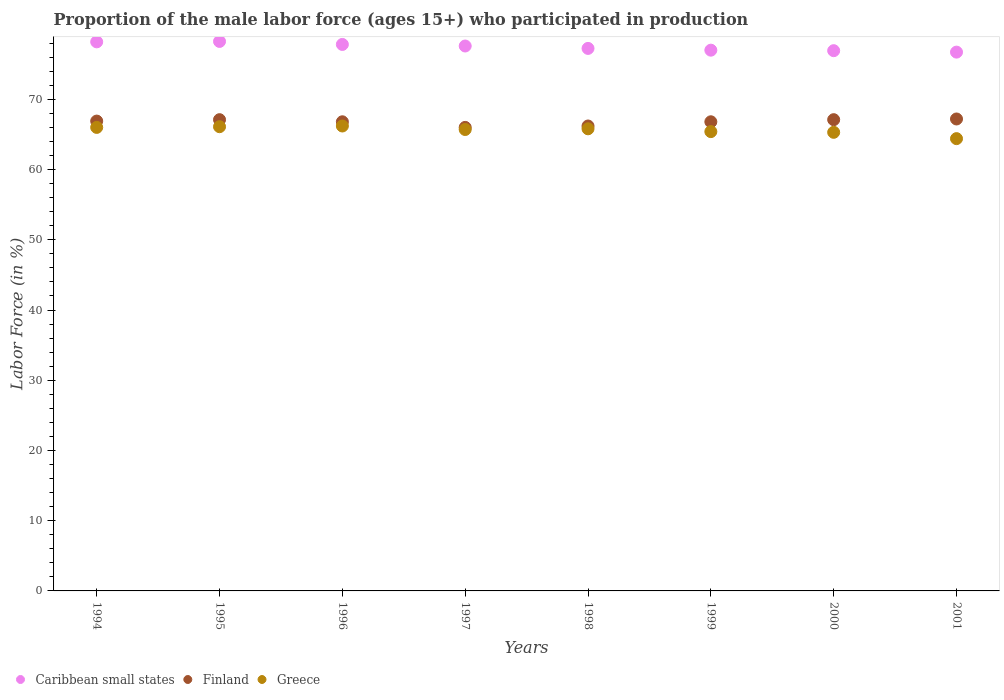How many different coloured dotlines are there?
Give a very brief answer. 3. Is the number of dotlines equal to the number of legend labels?
Your answer should be very brief. Yes. What is the proportion of the male labor force who participated in production in Caribbean small states in 1998?
Keep it short and to the point. 77.25. Across all years, what is the maximum proportion of the male labor force who participated in production in Greece?
Offer a terse response. 66.2. Across all years, what is the minimum proportion of the male labor force who participated in production in Greece?
Ensure brevity in your answer.  64.4. In which year was the proportion of the male labor force who participated in production in Finland minimum?
Ensure brevity in your answer.  1997. What is the total proportion of the male labor force who participated in production in Greece in the graph?
Your answer should be compact. 524.9. What is the difference between the proportion of the male labor force who participated in production in Caribbean small states in 1996 and that in 1999?
Offer a terse response. 0.82. What is the difference between the proportion of the male labor force who participated in production in Greece in 1994 and the proportion of the male labor force who participated in production in Caribbean small states in 1995?
Offer a terse response. -12.24. What is the average proportion of the male labor force who participated in production in Caribbean small states per year?
Provide a short and direct response. 77.46. In the year 2001, what is the difference between the proportion of the male labor force who participated in production in Caribbean small states and proportion of the male labor force who participated in production in Finland?
Your response must be concise. 9.52. In how many years, is the proportion of the male labor force who participated in production in Caribbean small states greater than 66 %?
Provide a succinct answer. 8. What is the ratio of the proportion of the male labor force who participated in production in Greece in 1997 to that in 1999?
Keep it short and to the point. 1. Is the proportion of the male labor force who participated in production in Greece in 2000 less than that in 2001?
Offer a terse response. No. Is the difference between the proportion of the male labor force who participated in production in Caribbean small states in 1997 and 1999 greater than the difference between the proportion of the male labor force who participated in production in Finland in 1997 and 1999?
Make the answer very short. Yes. What is the difference between the highest and the second highest proportion of the male labor force who participated in production in Caribbean small states?
Ensure brevity in your answer.  0.06. What is the difference between the highest and the lowest proportion of the male labor force who participated in production in Caribbean small states?
Keep it short and to the point. 1.52. Is it the case that in every year, the sum of the proportion of the male labor force who participated in production in Caribbean small states and proportion of the male labor force who participated in production in Finland  is greater than the proportion of the male labor force who participated in production in Greece?
Make the answer very short. Yes. Does the proportion of the male labor force who participated in production in Greece monotonically increase over the years?
Give a very brief answer. No. Is the proportion of the male labor force who participated in production in Greece strictly greater than the proportion of the male labor force who participated in production in Finland over the years?
Ensure brevity in your answer.  No. Is the proportion of the male labor force who participated in production in Finland strictly less than the proportion of the male labor force who participated in production in Caribbean small states over the years?
Offer a terse response. Yes. How many years are there in the graph?
Your answer should be compact. 8. Does the graph contain any zero values?
Offer a terse response. No. Does the graph contain grids?
Your answer should be very brief. No. What is the title of the graph?
Your answer should be compact. Proportion of the male labor force (ages 15+) who participated in production. What is the label or title of the Y-axis?
Keep it short and to the point. Labor Force (in %). What is the Labor Force (in %) in Caribbean small states in 1994?
Offer a very short reply. 78.18. What is the Labor Force (in %) in Finland in 1994?
Offer a very short reply. 66.9. What is the Labor Force (in %) in Greece in 1994?
Give a very brief answer. 66. What is the Labor Force (in %) in Caribbean small states in 1995?
Provide a succinct answer. 78.24. What is the Labor Force (in %) in Finland in 1995?
Offer a terse response. 67.1. What is the Labor Force (in %) of Greece in 1995?
Your response must be concise. 66.1. What is the Labor Force (in %) in Caribbean small states in 1996?
Your answer should be compact. 77.81. What is the Labor Force (in %) of Finland in 1996?
Provide a succinct answer. 66.8. What is the Labor Force (in %) in Greece in 1996?
Keep it short and to the point. 66.2. What is the Labor Force (in %) of Caribbean small states in 1997?
Offer a very short reply. 77.59. What is the Labor Force (in %) in Finland in 1997?
Offer a terse response. 66. What is the Labor Force (in %) of Greece in 1997?
Offer a very short reply. 65.7. What is the Labor Force (in %) of Caribbean small states in 1998?
Your answer should be very brief. 77.25. What is the Labor Force (in %) of Finland in 1998?
Offer a very short reply. 66.2. What is the Labor Force (in %) in Greece in 1998?
Provide a short and direct response. 65.8. What is the Labor Force (in %) in Caribbean small states in 1999?
Your answer should be very brief. 77. What is the Labor Force (in %) in Finland in 1999?
Make the answer very short. 66.8. What is the Labor Force (in %) of Greece in 1999?
Provide a succinct answer. 65.4. What is the Labor Force (in %) of Caribbean small states in 2000?
Keep it short and to the point. 76.92. What is the Labor Force (in %) of Finland in 2000?
Provide a succinct answer. 67.1. What is the Labor Force (in %) of Greece in 2000?
Provide a short and direct response. 65.3. What is the Labor Force (in %) of Caribbean small states in 2001?
Keep it short and to the point. 76.72. What is the Labor Force (in %) in Finland in 2001?
Your answer should be compact. 67.2. What is the Labor Force (in %) in Greece in 2001?
Make the answer very short. 64.4. Across all years, what is the maximum Labor Force (in %) of Caribbean small states?
Provide a short and direct response. 78.24. Across all years, what is the maximum Labor Force (in %) of Finland?
Provide a short and direct response. 67.2. Across all years, what is the maximum Labor Force (in %) of Greece?
Make the answer very short. 66.2. Across all years, what is the minimum Labor Force (in %) in Caribbean small states?
Make the answer very short. 76.72. Across all years, what is the minimum Labor Force (in %) of Greece?
Your answer should be compact. 64.4. What is the total Labor Force (in %) of Caribbean small states in the graph?
Ensure brevity in your answer.  619.71. What is the total Labor Force (in %) of Finland in the graph?
Keep it short and to the point. 534.1. What is the total Labor Force (in %) of Greece in the graph?
Offer a terse response. 524.9. What is the difference between the Labor Force (in %) of Caribbean small states in 1994 and that in 1995?
Provide a short and direct response. -0.06. What is the difference between the Labor Force (in %) of Greece in 1994 and that in 1995?
Provide a short and direct response. -0.1. What is the difference between the Labor Force (in %) in Caribbean small states in 1994 and that in 1996?
Provide a succinct answer. 0.37. What is the difference between the Labor Force (in %) in Greece in 1994 and that in 1996?
Provide a succinct answer. -0.2. What is the difference between the Labor Force (in %) of Caribbean small states in 1994 and that in 1997?
Offer a terse response. 0.59. What is the difference between the Labor Force (in %) in Finland in 1994 and that in 1997?
Your answer should be compact. 0.9. What is the difference between the Labor Force (in %) in Caribbean small states in 1994 and that in 1998?
Your answer should be compact. 0.94. What is the difference between the Labor Force (in %) of Greece in 1994 and that in 1998?
Make the answer very short. 0.2. What is the difference between the Labor Force (in %) of Caribbean small states in 1994 and that in 1999?
Offer a terse response. 1.19. What is the difference between the Labor Force (in %) in Caribbean small states in 1994 and that in 2000?
Your answer should be very brief. 1.26. What is the difference between the Labor Force (in %) in Finland in 1994 and that in 2000?
Give a very brief answer. -0.2. What is the difference between the Labor Force (in %) in Greece in 1994 and that in 2000?
Provide a succinct answer. 0.7. What is the difference between the Labor Force (in %) of Caribbean small states in 1994 and that in 2001?
Provide a short and direct response. 1.46. What is the difference between the Labor Force (in %) of Finland in 1994 and that in 2001?
Keep it short and to the point. -0.3. What is the difference between the Labor Force (in %) of Caribbean small states in 1995 and that in 1996?
Make the answer very short. 0.43. What is the difference between the Labor Force (in %) of Greece in 1995 and that in 1996?
Your answer should be compact. -0.1. What is the difference between the Labor Force (in %) of Caribbean small states in 1995 and that in 1997?
Keep it short and to the point. 0.65. What is the difference between the Labor Force (in %) of Greece in 1995 and that in 1997?
Ensure brevity in your answer.  0.4. What is the difference between the Labor Force (in %) in Caribbean small states in 1995 and that in 1998?
Provide a succinct answer. 0.99. What is the difference between the Labor Force (in %) of Finland in 1995 and that in 1998?
Your answer should be compact. 0.9. What is the difference between the Labor Force (in %) in Greece in 1995 and that in 1998?
Ensure brevity in your answer.  0.3. What is the difference between the Labor Force (in %) of Caribbean small states in 1995 and that in 1999?
Your response must be concise. 1.24. What is the difference between the Labor Force (in %) of Greece in 1995 and that in 1999?
Your response must be concise. 0.7. What is the difference between the Labor Force (in %) of Caribbean small states in 1995 and that in 2000?
Offer a terse response. 1.32. What is the difference between the Labor Force (in %) in Finland in 1995 and that in 2000?
Keep it short and to the point. 0. What is the difference between the Labor Force (in %) of Greece in 1995 and that in 2000?
Provide a succinct answer. 0.8. What is the difference between the Labor Force (in %) of Caribbean small states in 1995 and that in 2001?
Give a very brief answer. 1.52. What is the difference between the Labor Force (in %) of Finland in 1995 and that in 2001?
Offer a terse response. -0.1. What is the difference between the Labor Force (in %) of Greece in 1995 and that in 2001?
Your answer should be very brief. 1.7. What is the difference between the Labor Force (in %) of Caribbean small states in 1996 and that in 1997?
Ensure brevity in your answer.  0.22. What is the difference between the Labor Force (in %) in Finland in 1996 and that in 1997?
Offer a terse response. 0.8. What is the difference between the Labor Force (in %) of Caribbean small states in 1996 and that in 1998?
Your answer should be very brief. 0.57. What is the difference between the Labor Force (in %) of Finland in 1996 and that in 1998?
Make the answer very short. 0.6. What is the difference between the Labor Force (in %) of Greece in 1996 and that in 1998?
Your answer should be compact. 0.4. What is the difference between the Labor Force (in %) of Caribbean small states in 1996 and that in 1999?
Your response must be concise. 0.82. What is the difference between the Labor Force (in %) of Caribbean small states in 1996 and that in 2000?
Your response must be concise. 0.89. What is the difference between the Labor Force (in %) of Greece in 1996 and that in 2000?
Ensure brevity in your answer.  0.9. What is the difference between the Labor Force (in %) of Caribbean small states in 1996 and that in 2001?
Give a very brief answer. 1.09. What is the difference between the Labor Force (in %) in Finland in 1996 and that in 2001?
Give a very brief answer. -0.4. What is the difference between the Labor Force (in %) in Caribbean small states in 1997 and that in 1998?
Offer a very short reply. 0.34. What is the difference between the Labor Force (in %) of Greece in 1997 and that in 1998?
Keep it short and to the point. -0.1. What is the difference between the Labor Force (in %) of Caribbean small states in 1997 and that in 1999?
Make the answer very short. 0.59. What is the difference between the Labor Force (in %) of Finland in 1997 and that in 1999?
Offer a terse response. -0.8. What is the difference between the Labor Force (in %) in Greece in 1997 and that in 1999?
Your answer should be compact. 0.3. What is the difference between the Labor Force (in %) of Caribbean small states in 1997 and that in 2000?
Offer a terse response. 0.67. What is the difference between the Labor Force (in %) of Greece in 1997 and that in 2000?
Keep it short and to the point. 0.4. What is the difference between the Labor Force (in %) of Caribbean small states in 1997 and that in 2001?
Offer a terse response. 0.87. What is the difference between the Labor Force (in %) of Caribbean small states in 1998 and that in 1999?
Offer a very short reply. 0.25. What is the difference between the Labor Force (in %) in Finland in 1998 and that in 1999?
Ensure brevity in your answer.  -0.6. What is the difference between the Labor Force (in %) in Greece in 1998 and that in 1999?
Offer a very short reply. 0.4. What is the difference between the Labor Force (in %) of Caribbean small states in 1998 and that in 2000?
Give a very brief answer. 0.32. What is the difference between the Labor Force (in %) in Finland in 1998 and that in 2000?
Ensure brevity in your answer.  -0.9. What is the difference between the Labor Force (in %) of Caribbean small states in 1998 and that in 2001?
Offer a terse response. 0.53. What is the difference between the Labor Force (in %) of Finland in 1998 and that in 2001?
Your answer should be very brief. -1. What is the difference between the Labor Force (in %) of Caribbean small states in 1999 and that in 2000?
Your answer should be very brief. 0.07. What is the difference between the Labor Force (in %) in Greece in 1999 and that in 2000?
Keep it short and to the point. 0.1. What is the difference between the Labor Force (in %) in Caribbean small states in 1999 and that in 2001?
Offer a terse response. 0.28. What is the difference between the Labor Force (in %) in Greece in 1999 and that in 2001?
Your answer should be compact. 1. What is the difference between the Labor Force (in %) in Caribbean small states in 2000 and that in 2001?
Ensure brevity in your answer.  0.2. What is the difference between the Labor Force (in %) in Finland in 2000 and that in 2001?
Give a very brief answer. -0.1. What is the difference between the Labor Force (in %) in Caribbean small states in 1994 and the Labor Force (in %) in Finland in 1995?
Give a very brief answer. 11.08. What is the difference between the Labor Force (in %) in Caribbean small states in 1994 and the Labor Force (in %) in Greece in 1995?
Ensure brevity in your answer.  12.08. What is the difference between the Labor Force (in %) of Finland in 1994 and the Labor Force (in %) of Greece in 1995?
Your answer should be compact. 0.8. What is the difference between the Labor Force (in %) of Caribbean small states in 1994 and the Labor Force (in %) of Finland in 1996?
Ensure brevity in your answer.  11.38. What is the difference between the Labor Force (in %) in Caribbean small states in 1994 and the Labor Force (in %) in Greece in 1996?
Keep it short and to the point. 11.98. What is the difference between the Labor Force (in %) in Finland in 1994 and the Labor Force (in %) in Greece in 1996?
Provide a succinct answer. 0.7. What is the difference between the Labor Force (in %) of Caribbean small states in 1994 and the Labor Force (in %) of Finland in 1997?
Offer a terse response. 12.18. What is the difference between the Labor Force (in %) in Caribbean small states in 1994 and the Labor Force (in %) in Greece in 1997?
Ensure brevity in your answer.  12.48. What is the difference between the Labor Force (in %) of Finland in 1994 and the Labor Force (in %) of Greece in 1997?
Make the answer very short. 1.2. What is the difference between the Labor Force (in %) in Caribbean small states in 1994 and the Labor Force (in %) in Finland in 1998?
Provide a short and direct response. 11.98. What is the difference between the Labor Force (in %) of Caribbean small states in 1994 and the Labor Force (in %) of Greece in 1998?
Offer a very short reply. 12.38. What is the difference between the Labor Force (in %) of Finland in 1994 and the Labor Force (in %) of Greece in 1998?
Keep it short and to the point. 1.1. What is the difference between the Labor Force (in %) in Caribbean small states in 1994 and the Labor Force (in %) in Finland in 1999?
Provide a short and direct response. 11.38. What is the difference between the Labor Force (in %) in Caribbean small states in 1994 and the Labor Force (in %) in Greece in 1999?
Your response must be concise. 12.78. What is the difference between the Labor Force (in %) in Finland in 1994 and the Labor Force (in %) in Greece in 1999?
Offer a terse response. 1.5. What is the difference between the Labor Force (in %) in Caribbean small states in 1994 and the Labor Force (in %) in Finland in 2000?
Make the answer very short. 11.08. What is the difference between the Labor Force (in %) of Caribbean small states in 1994 and the Labor Force (in %) of Greece in 2000?
Your response must be concise. 12.88. What is the difference between the Labor Force (in %) of Caribbean small states in 1994 and the Labor Force (in %) of Finland in 2001?
Your answer should be compact. 10.98. What is the difference between the Labor Force (in %) in Caribbean small states in 1994 and the Labor Force (in %) in Greece in 2001?
Give a very brief answer. 13.78. What is the difference between the Labor Force (in %) of Finland in 1994 and the Labor Force (in %) of Greece in 2001?
Your answer should be compact. 2.5. What is the difference between the Labor Force (in %) in Caribbean small states in 1995 and the Labor Force (in %) in Finland in 1996?
Offer a terse response. 11.44. What is the difference between the Labor Force (in %) of Caribbean small states in 1995 and the Labor Force (in %) of Greece in 1996?
Give a very brief answer. 12.04. What is the difference between the Labor Force (in %) in Caribbean small states in 1995 and the Labor Force (in %) in Finland in 1997?
Offer a very short reply. 12.24. What is the difference between the Labor Force (in %) of Caribbean small states in 1995 and the Labor Force (in %) of Greece in 1997?
Ensure brevity in your answer.  12.54. What is the difference between the Labor Force (in %) in Finland in 1995 and the Labor Force (in %) in Greece in 1997?
Provide a succinct answer. 1.4. What is the difference between the Labor Force (in %) of Caribbean small states in 1995 and the Labor Force (in %) of Finland in 1998?
Give a very brief answer. 12.04. What is the difference between the Labor Force (in %) of Caribbean small states in 1995 and the Labor Force (in %) of Greece in 1998?
Offer a terse response. 12.44. What is the difference between the Labor Force (in %) in Finland in 1995 and the Labor Force (in %) in Greece in 1998?
Your answer should be very brief. 1.3. What is the difference between the Labor Force (in %) of Caribbean small states in 1995 and the Labor Force (in %) of Finland in 1999?
Provide a succinct answer. 11.44. What is the difference between the Labor Force (in %) of Caribbean small states in 1995 and the Labor Force (in %) of Greece in 1999?
Provide a succinct answer. 12.84. What is the difference between the Labor Force (in %) in Finland in 1995 and the Labor Force (in %) in Greece in 1999?
Your response must be concise. 1.7. What is the difference between the Labor Force (in %) of Caribbean small states in 1995 and the Labor Force (in %) of Finland in 2000?
Your answer should be very brief. 11.14. What is the difference between the Labor Force (in %) of Caribbean small states in 1995 and the Labor Force (in %) of Greece in 2000?
Your answer should be compact. 12.94. What is the difference between the Labor Force (in %) of Caribbean small states in 1995 and the Labor Force (in %) of Finland in 2001?
Your response must be concise. 11.04. What is the difference between the Labor Force (in %) of Caribbean small states in 1995 and the Labor Force (in %) of Greece in 2001?
Your answer should be very brief. 13.84. What is the difference between the Labor Force (in %) in Caribbean small states in 1996 and the Labor Force (in %) in Finland in 1997?
Ensure brevity in your answer.  11.81. What is the difference between the Labor Force (in %) in Caribbean small states in 1996 and the Labor Force (in %) in Greece in 1997?
Provide a short and direct response. 12.11. What is the difference between the Labor Force (in %) in Caribbean small states in 1996 and the Labor Force (in %) in Finland in 1998?
Offer a terse response. 11.61. What is the difference between the Labor Force (in %) in Caribbean small states in 1996 and the Labor Force (in %) in Greece in 1998?
Your answer should be very brief. 12.01. What is the difference between the Labor Force (in %) in Finland in 1996 and the Labor Force (in %) in Greece in 1998?
Give a very brief answer. 1. What is the difference between the Labor Force (in %) in Caribbean small states in 1996 and the Labor Force (in %) in Finland in 1999?
Your answer should be compact. 11.01. What is the difference between the Labor Force (in %) of Caribbean small states in 1996 and the Labor Force (in %) of Greece in 1999?
Provide a short and direct response. 12.41. What is the difference between the Labor Force (in %) of Finland in 1996 and the Labor Force (in %) of Greece in 1999?
Provide a succinct answer. 1.4. What is the difference between the Labor Force (in %) in Caribbean small states in 1996 and the Labor Force (in %) in Finland in 2000?
Offer a terse response. 10.71. What is the difference between the Labor Force (in %) of Caribbean small states in 1996 and the Labor Force (in %) of Greece in 2000?
Give a very brief answer. 12.51. What is the difference between the Labor Force (in %) in Finland in 1996 and the Labor Force (in %) in Greece in 2000?
Offer a very short reply. 1.5. What is the difference between the Labor Force (in %) of Caribbean small states in 1996 and the Labor Force (in %) of Finland in 2001?
Keep it short and to the point. 10.61. What is the difference between the Labor Force (in %) of Caribbean small states in 1996 and the Labor Force (in %) of Greece in 2001?
Keep it short and to the point. 13.41. What is the difference between the Labor Force (in %) of Caribbean small states in 1997 and the Labor Force (in %) of Finland in 1998?
Make the answer very short. 11.39. What is the difference between the Labor Force (in %) of Caribbean small states in 1997 and the Labor Force (in %) of Greece in 1998?
Give a very brief answer. 11.79. What is the difference between the Labor Force (in %) in Caribbean small states in 1997 and the Labor Force (in %) in Finland in 1999?
Ensure brevity in your answer.  10.79. What is the difference between the Labor Force (in %) of Caribbean small states in 1997 and the Labor Force (in %) of Greece in 1999?
Your answer should be very brief. 12.19. What is the difference between the Labor Force (in %) of Caribbean small states in 1997 and the Labor Force (in %) of Finland in 2000?
Make the answer very short. 10.49. What is the difference between the Labor Force (in %) in Caribbean small states in 1997 and the Labor Force (in %) in Greece in 2000?
Your answer should be very brief. 12.29. What is the difference between the Labor Force (in %) in Caribbean small states in 1997 and the Labor Force (in %) in Finland in 2001?
Your answer should be very brief. 10.39. What is the difference between the Labor Force (in %) in Caribbean small states in 1997 and the Labor Force (in %) in Greece in 2001?
Offer a terse response. 13.19. What is the difference between the Labor Force (in %) in Caribbean small states in 1998 and the Labor Force (in %) in Finland in 1999?
Give a very brief answer. 10.45. What is the difference between the Labor Force (in %) of Caribbean small states in 1998 and the Labor Force (in %) of Greece in 1999?
Offer a terse response. 11.85. What is the difference between the Labor Force (in %) of Finland in 1998 and the Labor Force (in %) of Greece in 1999?
Ensure brevity in your answer.  0.8. What is the difference between the Labor Force (in %) in Caribbean small states in 1998 and the Labor Force (in %) in Finland in 2000?
Provide a short and direct response. 10.15. What is the difference between the Labor Force (in %) of Caribbean small states in 1998 and the Labor Force (in %) of Greece in 2000?
Offer a very short reply. 11.95. What is the difference between the Labor Force (in %) of Finland in 1998 and the Labor Force (in %) of Greece in 2000?
Ensure brevity in your answer.  0.9. What is the difference between the Labor Force (in %) in Caribbean small states in 1998 and the Labor Force (in %) in Finland in 2001?
Make the answer very short. 10.05. What is the difference between the Labor Force (in %) of Caribbean small states in 1998 and the Labor Force (in %) of Greece in 2001?
Your answer should be very brief. 12.85. What is the difference between the Labor Force (in %) of Caribbean small states in 1999 and the Labor Force (in %) of Finland in 2000?
Give a very brief answer. 9.9. What is the difference between the Labor Force (in %) of Caribbean small states in 1999 and the Labor Force (in %) of Greece in 2000?
Your answer should be very brief. 11.7. What is the difference between the Labor Force (in %) in Caribbean small states in 1999 and the Labor Force (in %) in Finland in 2001?
Keep it short and to the point. 9.8. What is the difference between the Labor Force (in %) of Caribbean small states in 1999 and the Labor Force (in %) of Greece in 2001?
Make the answer very short. 12.6. What is the difference between the Labor Force (in %) in Caribbean small states in 2000 and the Labor Force (in %) in Finland in 2001?
Ensure brevity in your answer.  9.72. What is the difference between the Labor Force (in %) of Caribbean small states in 2000 and the Labor Force (in %) of Greece in 2001?
Offer a very short reply. 12.52. What is the average Labor Force (in %) in Caribbean small states per year?
Provide a short and direct response. 77.46. What is the average Labor Force (in %) in Finland per year?
Your response must be concise. 66.76. What is the average Labor Force (in %) in Greece per year?
Provide a short and direct response. 65.61. In the year 1994, what is the difference between the Labor Force (in %) of Caribbean small states and Labor Force (in %) of Finland?
Offer a terse response. 11.28. In the year 1994, what is the difference between the Labor Force (in %) of Caribbean small states and Labor Force (in %) of Greece?
Your answer should be very brief. 12.18. In the year 1995, what is the difference between the Labor Force (in %) of Caribbean small states and Labor Force (in %) of Finland?
Provide a succinct answer. 11.14. In the year 1995, what is the difference between the Labor Force (in %) in Caribbean small states and Labor Force (in %) in Greece?
Offer a very short reply. 12.14. In the year 1996, what is the difference between the Labor Force (in %) of Caribbean small states and Labor Force (in %) of Finland?
Provide a succinct answer. 11.01. In the year 1996, what is the difference between the Labor Force (in %) in Caribbean small states and Labor Force (in %) in Greece?
Give a very brief answer. 11.61. In the year 1996, what is the difference between the Labor Force (in %) in Finland and Labor Force (in %) in Greece?
Keep it short and to the point. 0.6. In the year 1997, what is the difference between the Labor Force (in %) of Caribbean small states and Labor Force (in %) of Finland?
Offer a terse response. 11.59. In the year 1997, what is the difference between the Labor Force (in %) of Caribbean small states and Labor Force (in %) of Greece?
Your response must be concise. 11.89. In the year 1998, what is the difference between the Labor Force (in %) of Caribbean small states and Labor Force (in %) of Finland?
Offer a very short reply. 11.05. In the year 1998, what is the difference between the Labor Force (in %) of Caribbean small states and Labor Force (in %) of Greece?
Keep it short and to the point. 11.45. In the year 1998, what is the difference between the Labor Force (in %) of Finland and Labor Force (in %) of Greece?
Your response must be concise. 0.4. In the year 1999, what is the difference between the Labor Force (in %) of Caribbean small states and Labor Force (in %) of Finland?
Ensure brevity in your answer.  10.2. In the year 1999, what is the difference between the Labor Force (in %) in Caribbean small states and Labor Force (in %) in Greece?
Your answer should be compact. 11.6. In the year 2000, what is the difference between the Labor Force (in %) in Caribbean small states and Labor Force (in %) in Finland?
Make the answer very short. 9.82. In the year 2000, what is the difference between the Labor Force (in %) in Caribbean small states and Labor Force (in %) in Greece?
Offer a very short reply. 11.62. In the year 2001, what is the difference between the Labor Force (in %) of Caribbean small states and Labor Force (in %) of Finland?
Offer a terse response. 9.52. In the year 2001, what is the difference between the Labor Force (in %) of Caribbean small states and Labor Force (in %) of Greece?
Your response must be concise. 12.32. In the year 2001, what is the difference between the Labor Force (in %) in Finland and Labor Force (in %) in Greece?
Provide a short and direct response. 2.8. What is the ratio of the Labor Force (in %) of Finland in 1994 to that in 1995?
Make the answer very short. 1. What is the ratio of the Labor Force (in %) in Caribbean small states in 1994 to that in 1996?
Ensure brevity in your answer.  1. What is the ratio of the Labor Force (in %) of Finland in 1994 to that in 1996?
Make the answer very short. 1. What is the ratio of the Labor Force (in %) in Greece in 1994 to that in 1996?
Keep it short and to the point. 1. What is the ratio of the Labor Force (in %) in Caribbean small states in 1994 to that in 1997?
Your answer should be compact. 1.01. What is the ratio of the Labor Force (in %) of Finland in 1994 to that in 1997?
Your response must be concise. 1.01. What is the ratio of the Labor Force (in %) of Greece in 1994 to that in 1997?
Provide a short and direct response. 1. What is the ratio of the Labor Force (in %) of Caribbean small states in 1994 to that in 1998?
Ensure brevity in your answer.  1.01. What is the ratio of the Labor Force (in %) of Finland in 1994 to that in 1998?
Make the answer very short. 1.01. What is the ratio of the Labor Force (in %) of Greece in 1994 to that in 1998?
Make the answer very short. 1. What is the ratio of the Labor Force (in %) in Caribbean small states in 1994 to that in 1999?
Provide a succinct answer. 1.02. What is the ratio of the Labor Force (in %) in Greece in 1994 to that in 1999?
Make the answer very short. 1.01. What is the ratio of the Labor Force (in %) in Caribbean small states in 1994 to that in 2000?
Offer a terse response. 1.02. What is the ratio of the Labor Force (in %) in Greece in 1994 to that in 2000?
Provide a succinct answer. 1.01. What is the ratio of the Labor Force (in %) in Caribbean small states in 1994 to that in 2001?
Offer a terse response. 1.02. What is the ratio of the Labor Force (in %) in Finland in 1994 to that in 2001?
Keep it short and to the point. 1. What is the ratio of the Labor Force (in %) in Greece in 1994 to that in 2001?
Your answer should be compact. 1.02. What is the ratio of the Labor Force (in %) in Caribbean small states in 1995 to that in 1996?
Your response must be concise. 1.01. What is the ratio of the Labor Force (in %) in Caribbean small states in 1995 to that in 1997?
Make the answer very short. 1.01. What is the ratio of the Labor Force (in %) of Finland in 1995 to that in 1997?
Your answer should be very brief. 1.02. What is the ratio of the Labor Force (in %) of Greece in 1995 to that in 1997?
Your answer should be compact. 1.01. What is the ratio of the Labor Force (in %) of Caribbean small states in 1995 to that in 1998?
Keep it short and to the point. 1.01. What is the ratio of the Labor Force (in %) of Finland in 1995 to that in 1998?
Ensure brevity in your answer.  1.01. What is the ratio of the Labor Force (in %) in Caribbean small states in 1995 to that in 1999?
Make the answer very short. 1.02. What is the ratio of the Labor Force (in %) of Greece in 1995 to that in 1999?
Provide a succinct answer. 1.01. What is the ratio of the Labor Force (in %) of Caribbean small states in 1995 to that in 2000?
Your answer should be very brief. 1.02. What is the ratio of the Labor Force (in %) in Finland in 1995 to that in 2000?
Provide a succinct answer. 1. What is the ratio of the Labor Force (in %) in Greece in 1995 to that in 2000?
Provide a succinct answer. 1.01. What is the ratio of the Labor Force (in %) in Caribbean small states in 1995 to that in 2001?
Provide a succinct answer. 1.02. What is the ratio of the Labor Force (in %) in Greece in 1995 to that in 2001?
Offer a very short reply. 1.03. What is the ratio of the Labor Force (in %) in Finland in 1996 to that in 1997?
Your answer should be compact. 1.01. What is the ratio of the Labor Force (in %) of Greece in 1996 to that in 1997?
Keep it short and to the point. 1.01. What is the ratio of the Labor Force (in %) of Caribbean small states in 1996 to that in 1998?
Your answer should be compact. 1.01. What is the ratio of the Labor Force (in %) of Finland in 1996 to that in 1998?
Ensure brevity in your answer.  1.01. What is the ratio of the Labor Force (in %) in Greece in 1996 to that in 1998?
Ensure brevity in your answer.  1.01. What is the ratio of the Labor Force (in %) in Caribbean small states in 1996 to that in 1999?
Provide a succinct answer. 1.01. What is the ratio of the Labor Force (in %) of Finland in 1996 to that in 1999?
Keep it short and to the point. 1. What is the ratio of the Labor Force (in %) of Greece in 1996 to that in 1999?
Provide a short and direct response. 1.01. What is the ratio of the Labor Force (in %) of Caribbean small states in 1996 to that in 2000?
Ensure brevity in your answer.  1.01. What is the ratio of the Labor Force (in %) of Greece in 1996 to that in 2000?
Your answer should be very brief. 1.01. What is the ratio of the Labor Force (in %) in Caribbean small states in 1996 to that in 2001?
Ensure brevity in your answer.  1.01. What is the ratio of the Labor Force (in %) in Finland in 1996 to that in 2001?
Make the answer very short. 0.99. What is the ratio of the Labor Force (in %) of Greece in 1996 to that in 2001?
Your response must be concise. 1.03. What is the ratio of the Labor Force (in %) in Caribbean small states in 1997 to that in 1998?
Provide a succinct answer. 1. What is the ratio of the Labor Force (in %) of Greece in 1997 to that in 1998?
Keep it short and to the point. 1. What is the ratio of the Labor Force (in %) in Caribbean small states in 1997 to that in 1999?
Ensure brevity in your answer.  1.01. What is the ratio of the Labor Force (in %) of Greece in 1997 to that in 1999?
Ensure brevity in your answer.  1. What is the ratio of the Labor Force (in %) of Caribbean small states in 1997 to that in 2000?
Offer a very short reply. 1.01. What is the ratio of the Labor Force (in %) in Finland in 1997 to that in 2000?
Keep it short and to the point. 0.98. What is the ratio of the Labor Force (in %) in Greece in 1997 to that in 2000?
Your answer should be very brief. 1.01. What is the ratio of the Labor Force (in %) of Caribbean small states in 1997 to that in 2001?
Your answer should be compact. 1.01. What is the ratio of the Labor Force (in %) in Finland in 1997 to that in 2001?
Keep it short and to the point. 0.98. What is the ratio of the Labor Force (in %) in Greece in 1997 to that in 2001?
Provide a short and direct response. 1.02. What is the ratio of the Labor Force (in %) of Greece in 1998 to that in 1999?
Make the answer very short. 1.01. What is the ratio of the Labor Force (in %) of Finland in 1998 to that in 2000?
Offer a terse response. 0.99. What is the ratio of the Labor Force (in %) in Greece in 1998 to that in 2000?
Offer a very short reply. 1.01. What is the ratio of the Labor Force (in %) of Finland in 1998 to that in 2001?
Offer a terse response. 0.99. What is the ratio of the Labor Force (in %) of Greece in 1998 to that in 2001?
Offer a very short reply. 1.02. What is the ratio of the Labor Force (in %) of Caribbean small states in 1999 to that in 2000?
Offer a terse response. 1. What is the ratio of the Labor Force (in %) of Greece in 1999 to that in 2000?
Your answer should be very brief. 1. What is the ratio of the Labor Force (in %) in Greece in 1999 to that in 2001?
Offer a very short reply. 1.02. What is the ratio of the Labor Force (in %) of Caribbean small states in 2000 to that in 2001?
Provide a short and direct response. 1. What is the ratio of the Labor Force (in %) of Finland in 2000 to that in 2001?
Offer a very short reply. 1. What is the difference between the highest and the second highest Labor Force (in %) of Caribbean small states?
Your answer should be compact. 0.06. What is the difference between the highest and the second highest Labor Force (in %) of Greece?
Your response must be concise. 0.1. What is the difference between the highest and the lowest Labor Force (in %) in Caribbean small states?
Your answer should be very brief. 1.52. What is the difference between the highest and the lowest Labor Force (in %) in Finland?
Your response must be concise. 1.2. What is the difference between the highest and the lowest Labor Force (in %) in Greece?
Offer a very short reply. 1.8. 